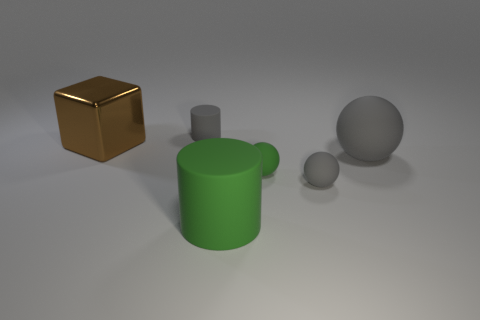Is there any other thing that is made of the same material as the large cube?
Keep it short and to the point. No. What size is the thing that is both behind the large ball and to the right of the cube?
Keep it short and to the point. Small. What number of other objects are the same shape as the big gray thing?
Keep it short and to the point. 2. Is the shape of the large gray rubber object the same as the small gray thing that is in front of the small cylinder?
Your answer should be compact. Yes. How many tiny matte cylinders are in front of the brown shiny block?
Your response must be concise. 0. Is the shape of the gray thing behind the metallic object the same as  the big gray rubber thing?
Provide a succinct answer. No. The cylinder that is in front of the brown shiny thing is what color?
Ensure brevity in your answer.  Green. There is a big green thing that is the same material as the tiny cylinder; what shape is it?
Your answer should be compact. Cylinder. Is there any other thing that has the same color as the big shiny block?
Give a very brief answer. No. Are there more green spheres that are on the left side of the large metallic block than balls that are in front of the big green thing?
Your answer should be compact. No. 